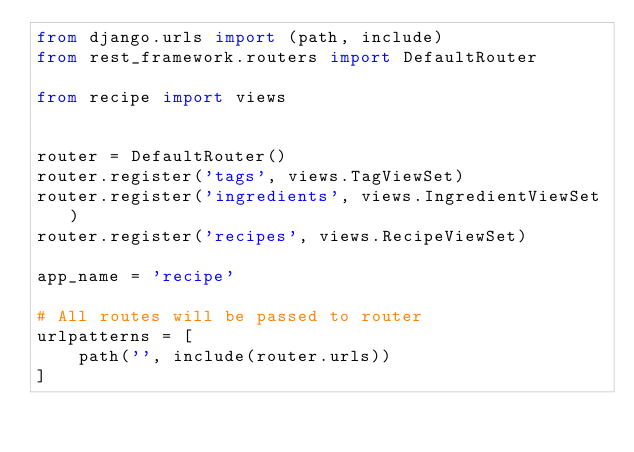Convert code to text. <code><loc_0><loc_0><loc_500><loc_500><_Python_>from django.urls import (path, include)
from rest_framework.routers import DefaultRouter

from recipe import views


router = DefaultRouter()
router.register('tags', views.TagViewSet)
router.register('ingredients', views.IngredientViewSet)
router.register('recipes', views.RecipeViewSet)

app_name = 'recipe'

# All routes will be passed to router
urlpatterns = [
    path('', include(router.urls))
]
</code> 